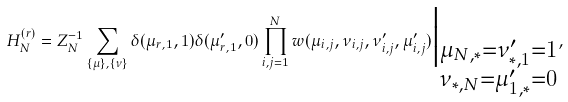<formula> <loc_0><loc_0><loc_500><loc_500>H _ { N } ^ { ( r ) } = Z _ { N } ^ { - 1 } \sum _ { \{ \mu \} , \{ \nu \} } \delta ( \mu _ { r , 1 } , 1 ) \delta ( \mu ^ { \prime } _ { r , 1 } , 0 ) \prod _ { i , j = 1 } ^ { N } w ( \mu _ { i , j } , \nu _ { i , j } , \nu _ { i , j } ^ { \prime } , \mu _ { i , j } ^ { \prime } ) \Big | _ { \substack { \mu _ { N , * } = \nu ^ { \prime } _ { * , 1 } = 1 \\ \nu _ { * , N } = \mu ^ { \prime } _ { 1 , * } = 0 } } ,</formula> 